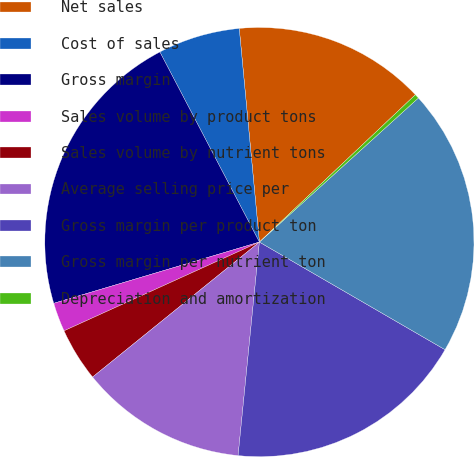Convert chart. <chart><loc_0><loc_0><loc_500><loc_500><pie_chart><fcel>Net sales<fcel>Cost of sales<fcel>Gross margin<fcel>Sales volume by product tons<fcel>Sales volume by nutrient tons<fcel>Average selling price per<fcel>Gross margin per product ton<fcel>Gross margin per nutrient ton<fcel>Depreciation and amortization<nl><fcel>14.45%<fcel>6.18%<fcel>21.93%<fcel>2.18%<fcel>4.04%<fcel>12.59%<fcel>18.22%<fcel>20.08%<fcel>0.33%<nl></chart> 